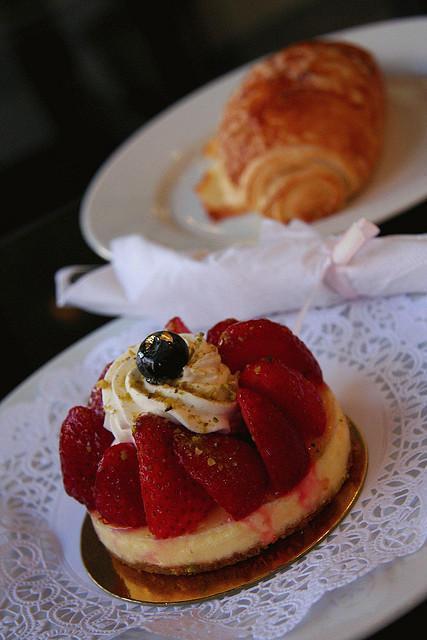How many desserts?
Give a very brief answer. 2. 